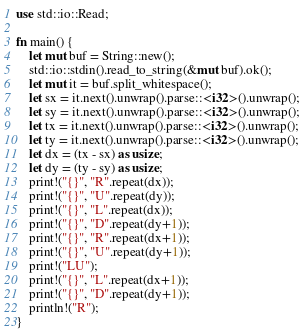Convert code to text. <code><loc_0><loc_0><loc_500><loc_500><_Rust_>use std::io::Read;

fn main() {
    let mut buf = String::new();
    std::io::stdin().read_to_string(&mut buf).ok();
    let mut it = buf.split_whitespace();
    let sx = it.next().unwrap().parse::<i32>().unwrap();
    let sy = it.next().unwrap().parse::<i32>().unwrap();
    let tx = it.next().unwrap().parse::<i32>().unwrap();
    let ty = it.next().unwrap().parse::<i32>().unwrap();
    let dx = (tx - sx) as usize;
    let dy = (ty - sy) as usize;
    print!("{}", "R".repeat(dx));
    print!("{}", "U".repeat(dy));
    print!("{}", "L".repeat(dx));
    print!("{}", "D".repeat(dy+1));
    print!("{}", "R".repeat(dx+1));
    print!("{}", "U".repeat(dy+1));
    print!("LU");
    print!("{}", "L".repeat(dx+1));
    print!("{}", "D".repeat(dy+1));
    println!("R");
}
</code> 